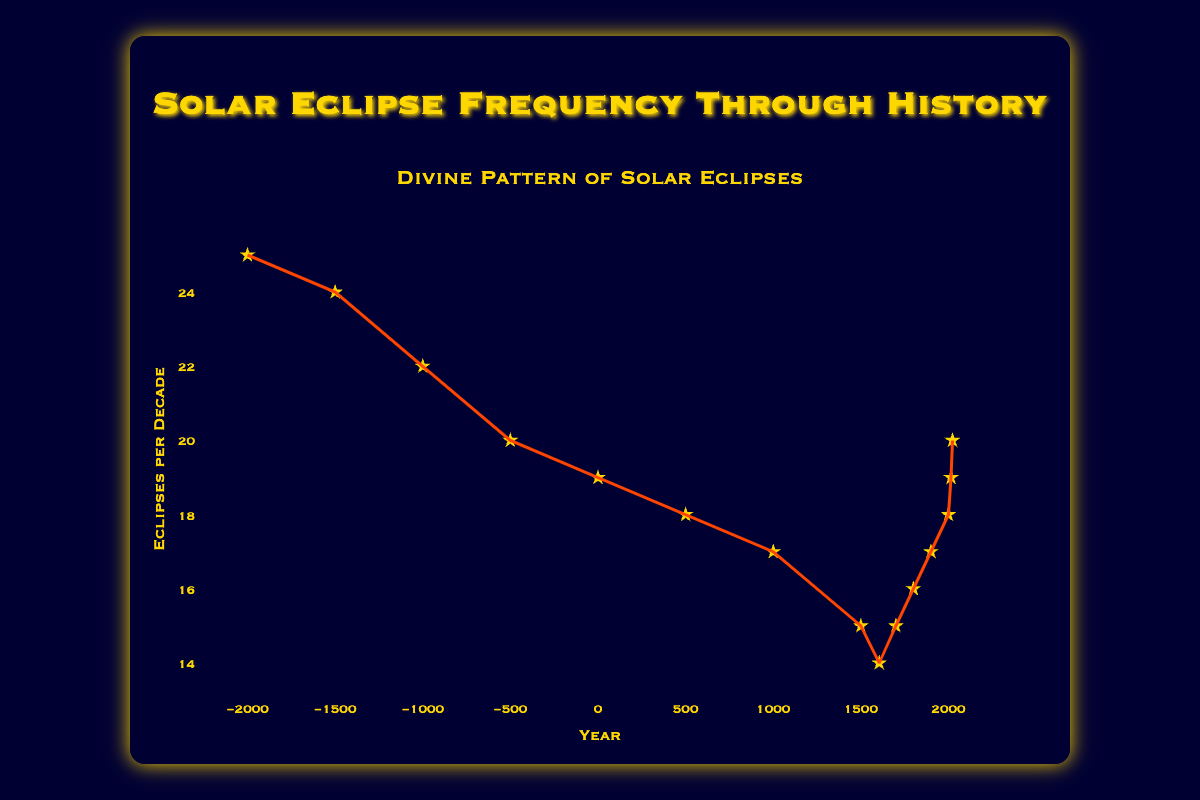what is the title of the plot? The title of the plot is displayed prominently at the top and reads "Divine Pattern of Solar Eclipses."
Answer: Divine Pattern of Solar Eclipses what information is provided along the x-axis? The x-axis is labeled "Year" and represents the timeline from 2000 BCE to 2023 CE.
Answer: Year what does the y-axis represent? The y-axis is labeled "Eclipses per Decade" and shows the frequency of solar eclipses occurring per decade.
Answer: Eclipses per Decade how many data points are plotted in this scatter plot? By counting each data point marked on the graph, we find there are 15 points representing different years.
Answer: 15 what is the trend in the frequency of solar eclipses from -2000 to 500 CE? The scatter plot and trend line indicate a decreasing trend in the number of solar eclipses per decade from 25 in -2000 to 18 in 500 CE.
Answer: Decreasing what is the frequency of solar eclipses per decade in the year 2023 CE? The plotted data point for the year 2023 shows that there are 20 solar eclipses per decade.
Answer: 20 compare the frequency of solar eclipses per decade in the years -500 and 500. which year had more eclipses per decade? In -500, there were 20 eclipses per decade, while in 500, there were 18. Therefore, -500 had more eclipses per decade.
Answer: -500 what trends are observable in the frequency of solar eclipses over the recent centuries (from 1500 to 2023 CE)? The data indicates that the frequency of solar eclipses declined from 15 in 1500 to a low of 14 in 1605, and then gradually increased, reaching 20 by 2023.
Answer: The frequency initially declined and then increased calculate the average number of eclipses per decade over the entire time period shown in the plot. Adding all the eclipse frequencies from the data points and dividing by 15 (the number of data points) yields the average frequency: (25+24+22+20+19+18+17+15+14+15+16+17+18+19+20)/15 = 18.2
Answer: 18.2 